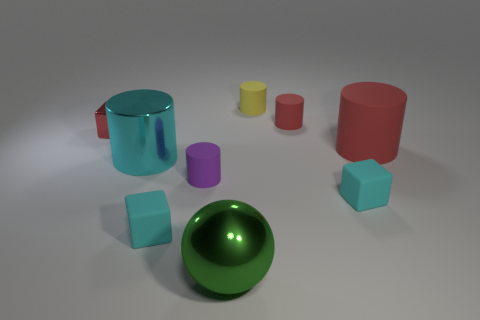Subtract all big red rubber cylinders. How many cylinders are left? 4 Subtract all yellow spheres. How many red cylinders are left? 2 Subtract 1 cylinders. How many cylinders are left? 4 Add 1 tiny red metal objects. How many objects exist? 10 Subtract all cyan cylinders. How many cylinders are left? 4 Subtract all green cylinders. Subtract all blue cubes. How many cylinders are left? 5 Subtract all tiny yellow cylinders. Subtract all green metal things. How many objects are left? 7 Add 5 tiny red matte cylinders. How many tiny red matte cylinders are left? 6 Add 9 green things. How many green things exist? 10 Subtract 2 cyan blocks. How many objects are left? 7 